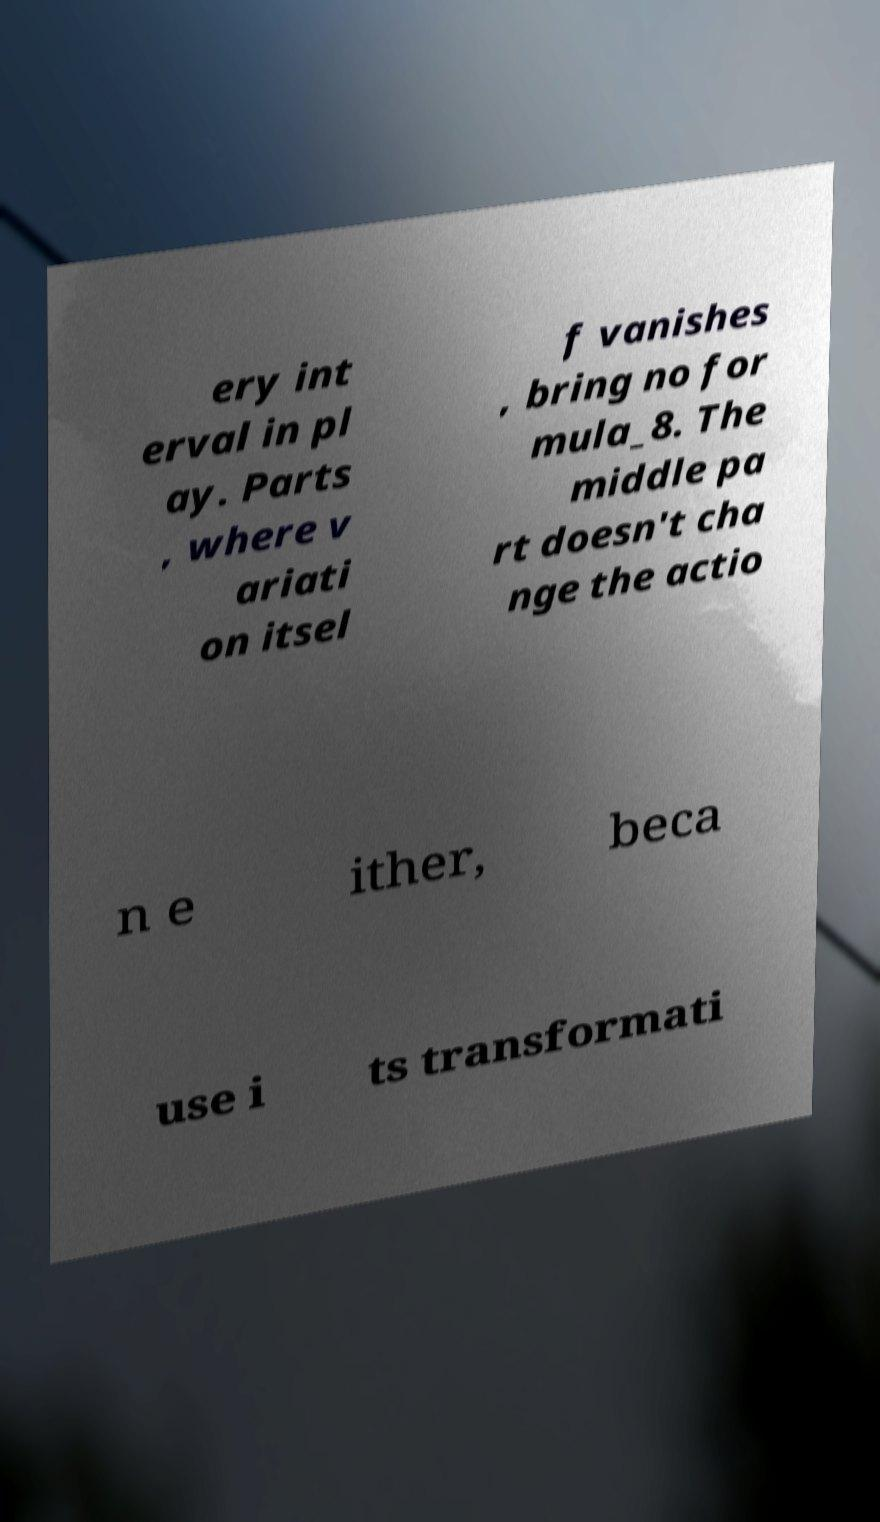Can you read and provide the text displayed in the image?This photo seems to have some interesting text. Can you extract and type it out for me? ery int erval in pl ay. Parts , where v ariati on itsel f vanishes , bring no for mula_8. The middle pa rt doesn't cha nge the actio n e ither, beca use i ts transformati 